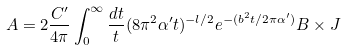Convert formula to latex. <formula><loc_0><loc_0><loc_500><loc_500>A = 2 \frac { C ^ { \prime } } { 4 \pi } \int _ { 0 } ^ { \infty } \frac { d t } { t } ( 8 \pi ^ { 2 } \alpha ^ { \prime } t ) ^ { - l / 2 } e ^ { - ( b ^ { 2 } t / 2 \pi \alpha ^ { \prime } ) } B \times J</formula> 